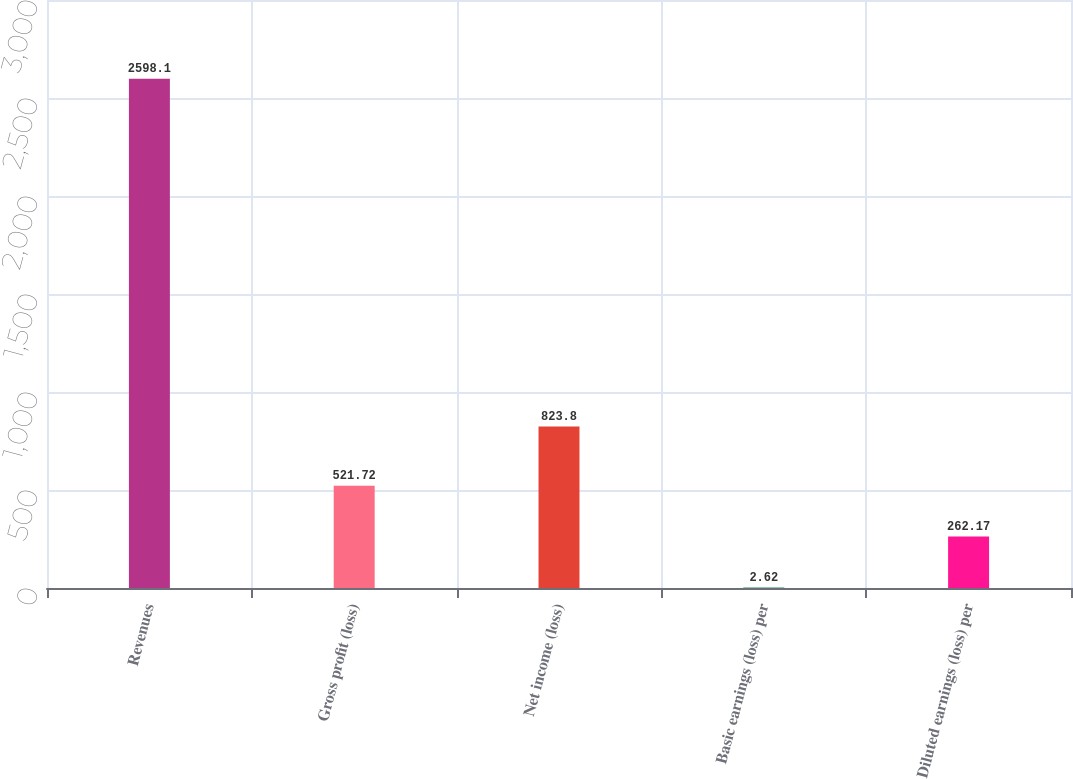Convert chart to OTSL. <chart><loc_0><loc_0><loc_500><loc_500><bar_chart><fcel>Revenues<fcel>Gross profit (loss)<fcel>Net income (loss)<fcel>Basic earnings (loss) per<fcel>Diluted earnings (loss) per<nl><fcel>2598.1<fcel>521.72<fcel>823.8<fcel>2.62<fcel>262.17<nl></chart> 